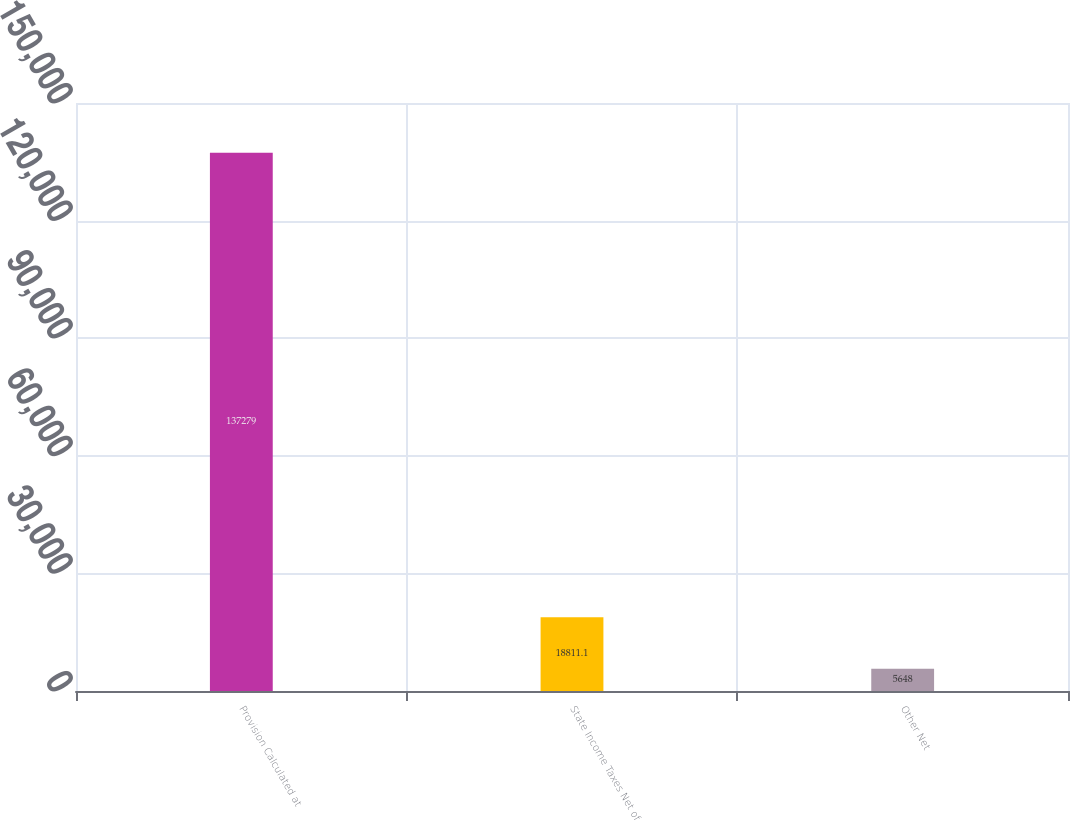Convert chart to OTSL. <chart><loc_0><loc_0><loc_500><loc_500><bar_chart><fcel>Provision Calculated at<fcel>State Income Taxes Net of<fcel>Other Net<nl><fcel>137279<fcel>18811.1<fcel>5648<nl></chart> 